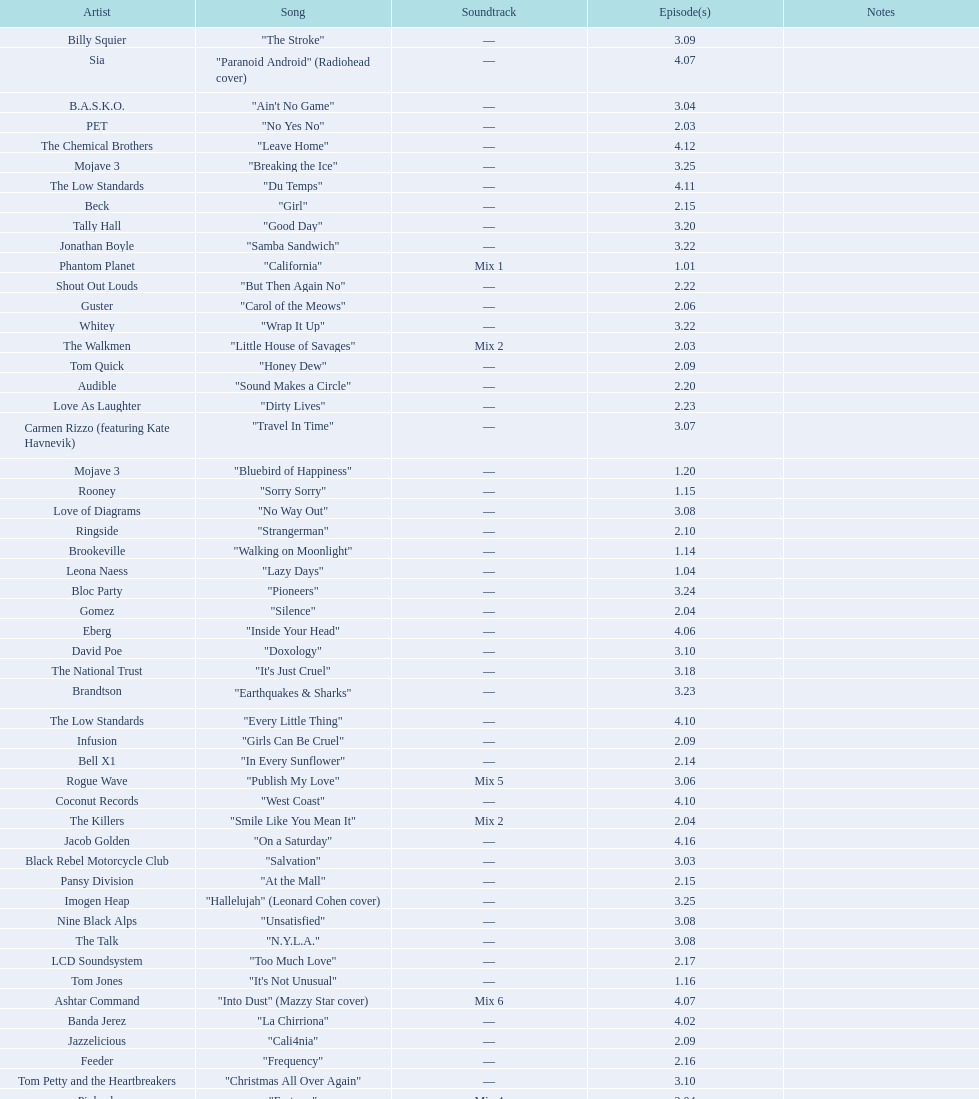How many consecutive songs were by the album leaf? 6. 